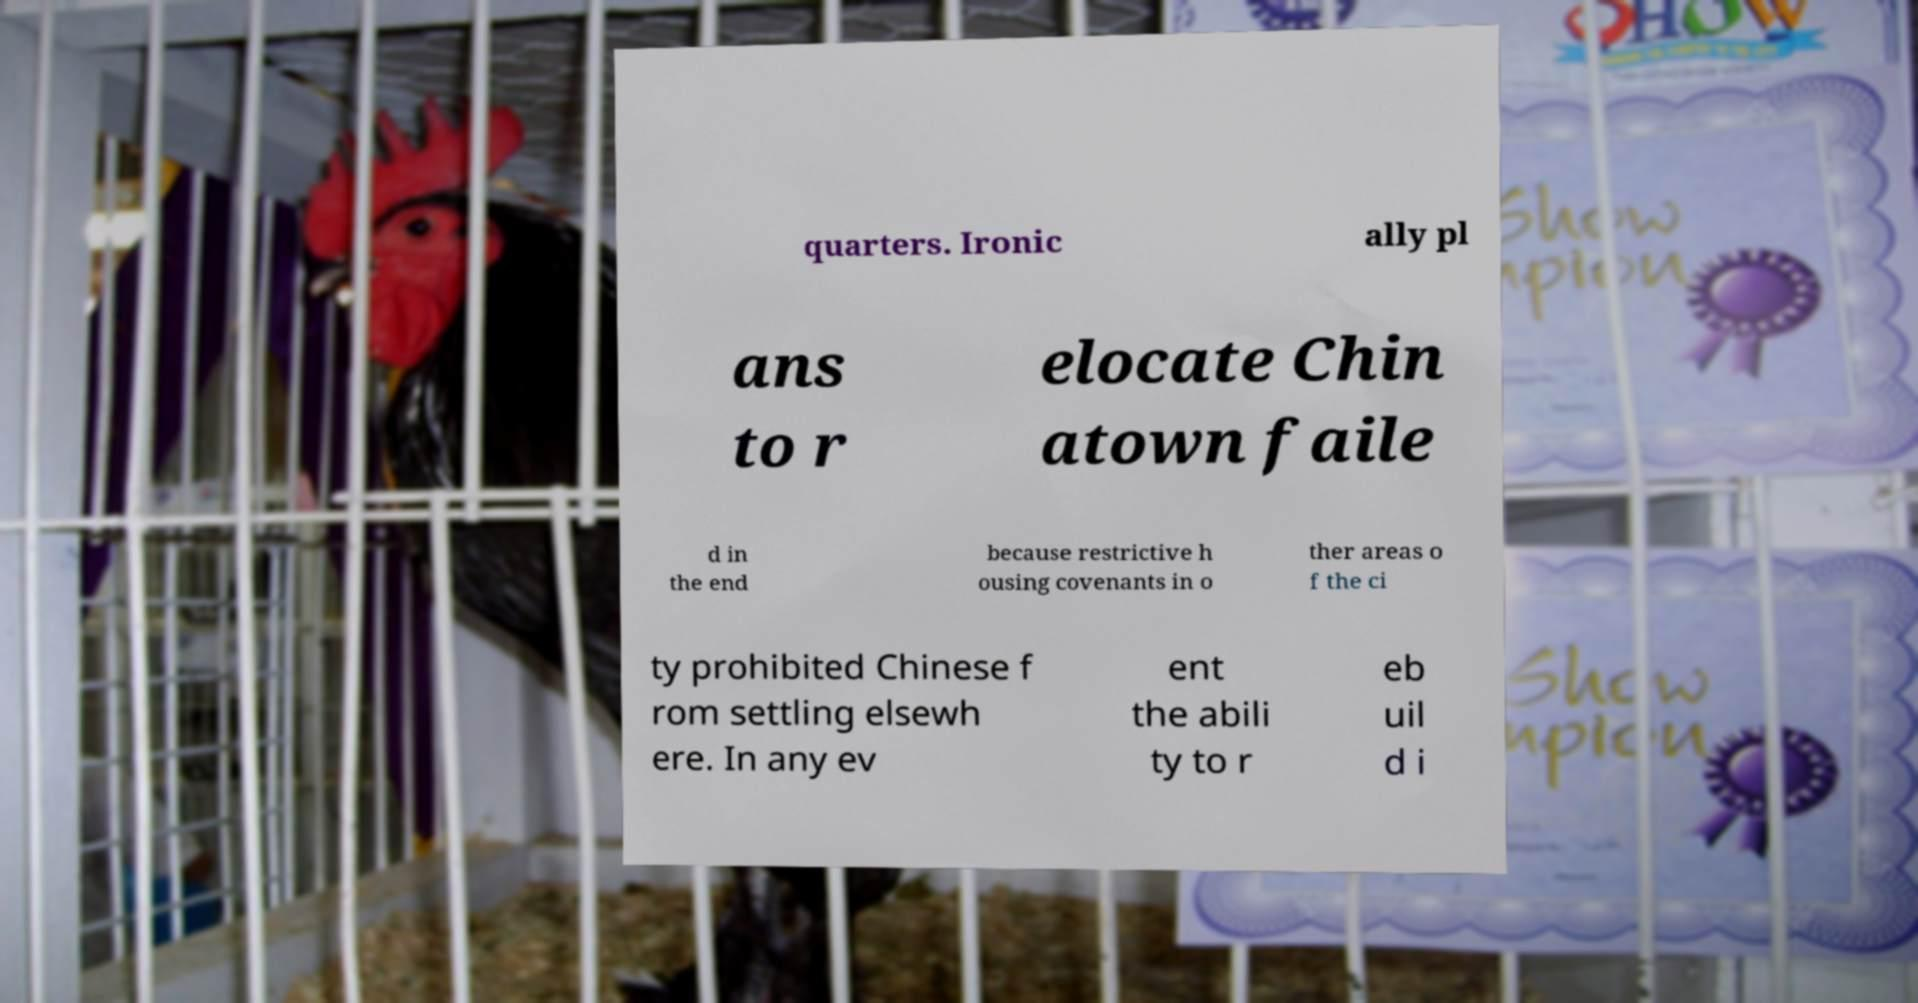Can you read and provide the text displayed in the image?This photo seems to have some interesting text. Can you extract and type it out for me? quarters. Ironic ally pl ans to r elocate Chin atown faile d in the end because restrictive h ousing covenants in o ther areas o f the ci ty prohibited Chinese f rom settling elsewh ere. In any ev ent the abili ty to r eb uil d i 